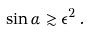Convert formula to latex. <formula><loc_0><loc_0><loc_500><loc_500>\sin \alpha \gtrsim \epsilon ^ { 2 } \, .</formula> 